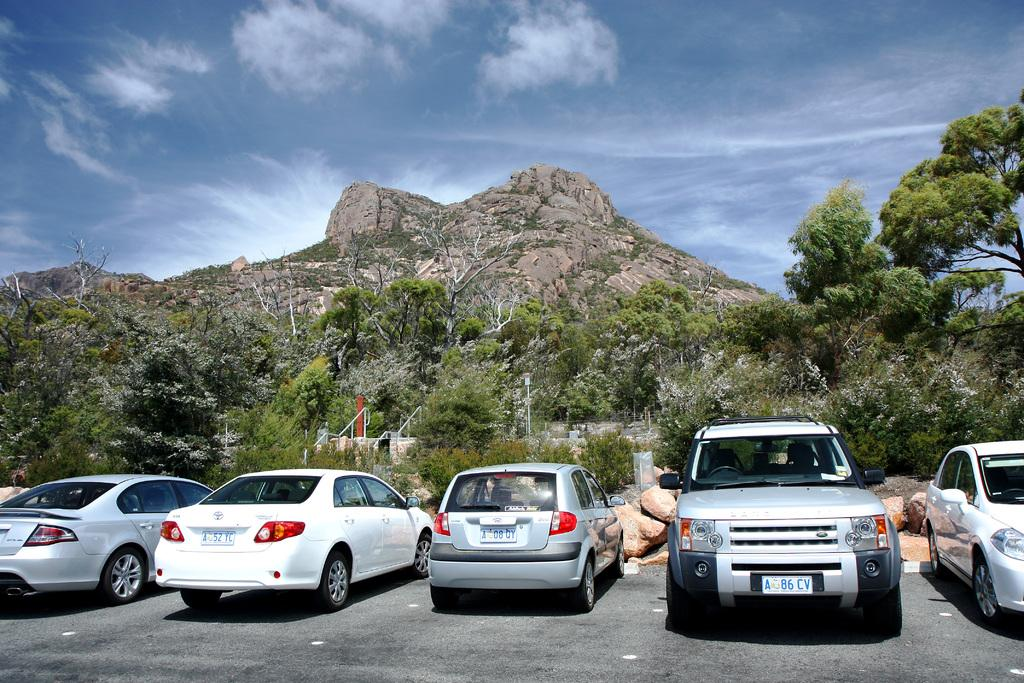What can be seen in the foreground of the image? There are cars parked in the foreground of the image. Where are the cars parked in relation to the road? The cars are parked beside the road. What can be seen in the background of the image? There are trees, poles, a mountain, and the sky visible in the background of the image. What is the condition of the sky in the image? The sky is visible in the background of the image, and there are clouds present. What type of jeans is the mountain wearing in the image? There are no jeans present in the image, as the mountain is a geological formation and not a person. What caption would best describe the action taking place in the image? There is no specific action taking place in the image, so it is difficult to provide a caption that accurately describes it. 